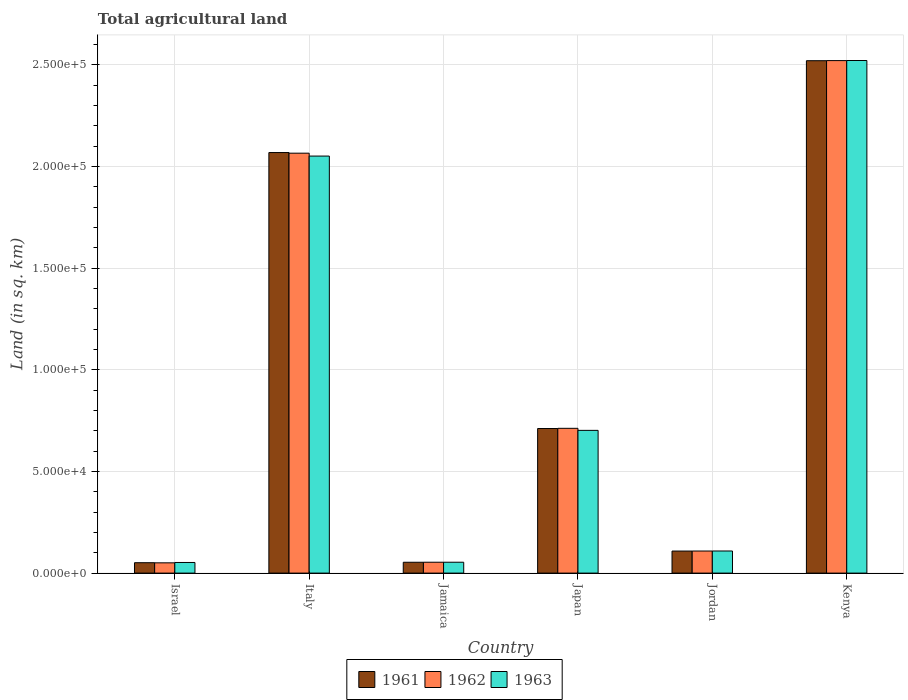Are the number of bars per tick equal to the number of legend labels?
Your answer should be compact. Yes. Are the number of bars on each tick of the X-axis equal?
Keep it short and to the point. Yes. How many bars are there on the 4th tick from the right?
Give a very brief answer. 3. What is the label of the 3rd group of bars from the left?
Make the answer very short. Jamaica. What is the total agricultural land in 1962 in Jamaica?
Provide a short and direct response. 5350. Across all countries, what is the maximum total agricultural land in 1962?
Provide a short and direct response. 2.52e+05. Across all countries, what is the minimum total agricultural land in 1961?
Offer a very short reply. 5110. In which country was the total agricultural land in 1962 maximum?
Your answer should be compact. Kenya. What is the total total agricultural land in 1961 in the graph?
Keep it short and to the point. 5.51e+05. What is the difference between the total agricultural land in 1962 in Jamaica and that in Japan?
Give a very brief answer. -6.58e+04. What is the difference between the total agricultural land in 1962 in Kenya and the total agricultural land in 1963 in Italy?
Give a very brief answer. 4.70e+04. What is the average total agricultural land in 1963 per country?
Offer a terse response. 9.15e+04. What is the ratio of the total agricultural land in 1961 in Italy to that in Jordan?
Ensure brevity in your answer.  19.08. What is the difference between the highest and the second highest total agricultural land in 1961?
Your answer should be very brief. 1.81e+05. What is the difference between the highest and the lowest total agricultural land in 1962?
Offer a very short reply. 2.47e+05. In how many countries, is the total agricultural land in 1963 greater than the average total agricultural land in 1963 taken over all countries?
Your response must be concise. 2. Is the sum of the total agricultural land in 1963 in Israel and Italy greater than the maximum total agricultural land in 1961 across all countries?
Make the answer very short. No. What does the 1st bar from the left in Jamaica represents?
Your response must be concise. 1961. What does the 1st bar from the right in Italy represents?
Give a very brief answer. 1963. Is it the case that in every country, the sum of the total agricultural land in 1962 and total agricultural land in 1963 is greater than the total agricultural land in 1961?
Your answer should be compact. Yes. Are all the bars in the graph horizontal?
Make the answer very short. No. How many countries are there in the graph?
Provide a succinct answer. 6. Are the values on the major ticks of Y-axis written in scientific E-notation?
Ensure brevity in your answer.  Yes. What is the title of the graph?
Offer a terse response. Total agricultural land. Does "1996" appear as one of the legend labels in the graph?
Your answer should be very brief. No. What is the label or title of the Y-axis?
Offer a very short reply. Land (in sq. km). What is the Land (in sq. km) in 1961 in Israel?
Provide a short and direct response. 5110. What is the Land (in sq. km) in 1962 in Israel?
Ensure brevity in your answer.  5050. What is the Land (in sq. km) in 1963 in Israel?
Your answer should be very brief. 5220. What is the Land (in sq. km) in 1961 in Italy?
Offer a terse response. 2.07e+05. What is the Land (in sq. km) in 1962 in Italy?
Keep it short and to the point. 2.07e+05. What is the Land (in sq. km) in 1963 in Italy?
Your response must be concise. 2.05e+05. What is the Land (in sq. km) in 1961 in Jamaica?
Your response must be concise. 5330. What is the Land (in sq. km) of 1962 in Jamaica?
Your response must be concise. 5350. What is the Land (in sq. km) of 1963 in Jamaica?
Give a very brief answer. 5350. What is the Land (in sq. km) in 1961 in Japan?
Make the answer very short. 7.11e+04. What is the Land (in sq. km) in 1962 in Japan?
Offer a terse response. 7.12e+04. What is the Land (in sq. km) of 1963 in Japan?
Keep it short and to the point. 7.02e+04. What is the Land (in sq. km) of 1961 in Jordan?
Your response must be concise. 1.08e+04. What is the Land (in sq. km) of 1962 in Jordan?
Your response must be concise. 1.09e+04. What is the Land (in sq. km) of 1963 in Jordan?
Your answer should be very brief. 1.09e+04. What is the Land (in sq. km) of 1961 in Kenya?
Your answer should be compact. 2.52e+05. What is the Land (in sq. km) in 1962 in Kenya?
Provide a short and direct response. 2.52e+05. What is the Land (in sq. km) in 1963 in Kenya?
Offer a very short reply. 2.52e+05. Across all countries, what is the maximum Land (in sq. km) in 1961?
Keep it short and to the point. 2.52e+05. Across all countries, what is the maximum Land (in sq. km) in 1962?
Offer a very short reply. 2.52e+05. Across all countries, what is the maximum Land (in sq. km) in 1963?
Make the answer very short. 2.52e+05. Across all countries, what is the minimum Land (in sq. km) of 1961?
Your answer should be compact. 5110. Across all countries, what is the minimum Land (in sq. km) of 1962?
Ensure brevity in your answer.  5050. Across all countries, what is the minimum Land (in sq. km) of 1963?
Ensure brevity in your answer.  5220. What is the total Land (in sq. km) of 1961 in the graph?
Keep it short and to the point. 5.51e+05. What is the total Land (in sq. km) of 1962 in the graph?
Ensure brevity in your answer.  5.51e+05. What is the total Land (in sq. km) of 1963 in the graph?
Make the answer very short. 5.49e+05. What is the difference between the Land (in sq. km) of 1961 in Israel and that in Italy?
Ensure brevity in your answer.  -2.02e+05. What is the difference between the Land (in sq. km) in 1962 in Israel and that in Italy?
Make the answer very short. -2.01e+05. What is the difference between the Land (in sq. km) of 1963 in Israel and that in Italy?
Offer a very short reply. -2.00e+05. What is the difference between the Land (in sq. km) in 1961 in Israel and that in Jamaica?
Provide a short and direct response. -220. What is the difference between the Land (in sq. km) in 1962 in Israel and that in Jamaica?
Keep it short and to the point. -300. What is the difference between the Land (in sq. km) of 1963 in Israel and that in Jamaica?
Ensure brevity in your answer.  -130. What is the difference between the Land (in sq. km) of 1961 in Israel and that in Japan?
Your answer should be compact. -6.60e+04. What is the difference between the Land (in sq. km) of 1962 in Israel and that in Japan?
Give a very brief answer. -6.62e+04. What is the difference between the Land (in sq. km) in 1963 in Israel and that in Japan?
Provide a succinct answer. -6.50e+04. What is the difference between the Land (in sq. km) of 1961 in Israel and that in Jordan?
Keep it short and to the point. -5730. What is the difference between the Land (in sq. km) in 1962 in Israel and that in Jordan?
Provide a short and direct response. -5810. What is the difference between the Land (in sq. km) in 1963 in Israel and that in Jordan?
Your response must be concise. -5650. What is the difference between the Land (in sq. km) of 1961 in Israel and that in Kenya?
Ensure brevity in your answer.  -2.47e+05. What is the difference between the Land (in sq. km) in 1962 in Israel and that in Kenya?
Ensure brevity in your answer.  -2.47e+05. What is the difference between the Land (in sq. km) in 1963 in Israel and that in Kenya?
Offer a very short reply. -2.47e+05. What is the difference between the Land (in sq. km) of 1961 in Italy and that in Jamaica?
Your response must be concise. 2.02e+05. What is the difference between the Land (in sq. km) in 1962 in Italy and that in Jamaica?
Your answer should be compact. 2.01e+05. What is the difference between the Land (in sq. km) of 1963 in Italy and that in Jamaica?
Keep it short and to the point. 2.00e+05. What is the difference between the Land (in sq. km) of 1961 in Italy and that in Japan?
Give a very brief answer. 1.36e+05. What is the difference between the Land (in sq. km) of 1962 in Italy and that in Japan?
Provide a short and direct response. 1.35e+05. What is the difference between the Land (in sq. km) in 1963 in Italy and that in Japan?
Ensure brevity in your answer.  1.35e+05. What is the difference between the Land (in sq. km) in 1961 in Italy and that in Jordan?
Your answer should be compact. 1.96e+05. What is the difference between the Land (in sq. km) in 1962 in Italy and that in Jordan?
Provide a short and direct response. 1.96e+05. What is the difference between the Land (in sq. km) of 1963 in Italy and that in Jordan?
Offer a terse response. 1.94e+05. What is the difference between the Land (in sq. km) of 1961 in Italy and that in Kenya?
Your answer should be compact. -4.52e+04. What is the difference between the Land (in sq. km) in 1962 in Italy and that in Kenya?
Your answer should be very brief. -4.55e+04. What is the difference between the Land (in sq. km) of 1963 in Italy and that in Kenya?
Provide a succinct answer. -4.70e+04. What is the difference between the Land (in sq. km) in 1961 in Jamaica and that in Japan?
Give a very brief answer. -6.58e+04. What is the difference between the Land (in sq. km) in 1962 in Jamaica and that in Japan?
Ensure brevity in your answer.  -6.58e+04. What is the difference between the Land (in sq. km) of 1963 in Jamaica and that in Japan?
Offer a very short reply. -6.48e+04. What is the difference between the Land (in sq. km) of 1961 in Jamaica and that in Jordan?
Provide a succinct answer. -5510. What is the difference between the Land (in sq. km) in 1962 in Jamaica and that in Jordan?
Keep it short and to the point. -5510. What is the difference between the Land (in sq. km) of 1963 in Jamaica and that in Jordan?
Ensure brevity in your answer.  -5520. What is the difference between the Land (in sq. km) of 1961 in Jamaica and that in Kenya?
Keep it short and to the point. -2.47e+05. What is the difference between the Land (in sq. km) in 1962 in Jamaica and that in Kenya?
Your answer should be very brief. -2.47e+05. What is the difference between the Land (in sq. km) of 1963 in Jamaica and that in Kenya?
Keep it short and to the point. -2.47e+05. What is the difference between the Land (in sq. km) of 1961 in Japan and that in Jordan?
Provide a succinct answer. 6.03e+04. What is the difference between the Land (in sq. km) in 1962 in Japan and that in Jordan?
Your response must be concise. 6.03e+04. What is the difference between the Land (in sq. km) of 1963 in Japan and that in Jordan?
Your response must be concise. 5.93e+04. What is the difference between the Land (in sq. km) in 1961 in Japan and that in Kenya?
Your response must be concise. -1.81e+05. What is the difference between the Land (in sq. km) of 1962 in Japan and that in Kenya?
Keep it short and to the point. -1.81e+05. What is the difference between the Land (in sq. km) of 1963 in Japan and that in Kenya?
Offer a very short reply. -1.82e+05. What is the difference between the Land (in sq. km) in 1961 in Jordan and that in Kenya?
Provide a succinct answer. -2.41e+05. What is the difference between the Land (in sq. km) of 1962 in Jordan and that in Kenya?
Your answer should be very brief. -2.41e+05. What is the difference between the Land (in sq. km) in 1963 in Jordan and that in Kenya?
Offer a terse response. -2.41e+05. What is the difference between the Land (in sq. km) of 1961 in Israel and the Land (in sq. km) of 1962 in Italy?
Your answer should be compact. -2.01e+05. What is the difference between the Land (in sq. km) in 1961 in Israel and the Land (in sq. km) in 1963 in Italy?
Give a very brief answer. -2.00e+05. What is the difference between the Land (in sq. km) in 1962 in Israel and the Land (in sq. km) in 1963 in Italy?
Give a very brief answer. -2.00e+05. What is the difference between the Land (in sq. km) in 1961 in Israel and the Land (in sq. km) in 1962 in Jamaica?
Your answer should be compact. -240. What is the difference between the Land (in sq. km) in 1961 in Israel and the Land (in sq. km) in 1963 in Jamaica?
Your answer should be compact. -240. What is the difference between the Land (in sq. km) of 1962 in Israel and the Land (in sq. km) of 1963 in Jamaica?
Your response must be concise. -300. What is the difference between the Land (in sq. km) in 1961 in Israel and the Land (in sq. km) in 1962 in Japan?
Make the answer very short. -6.61e+04. What is the difference between the Land (in sq. km) of 1961 in Israel and the Land (in sq. km) of 1963 in Japan?
Your answer should be compact. -6.51e+04. What is the difference between the Land (in sq. km) in 1962 in Israel and the Land (in sq. km) in 1963 in Japan?
Keep it short and to the point. -6.52e+04. What is the difference between the Land (in sq. km) in 1961 in Israel and the Land (in sq. km) in 1962 in Jordan?
Offer a terse response. -5750. What is the difference between the Land (in sq. km) in 1961 in Israel and the Land (in sq. km) in 1963 in Jordan?
Offer a terse response. -5760. What is the difference between the Land (in sq. km) of 1962 in Israel and the Land (in sq. km) of 1963 in Jordan?
Your answer should be compact. -5820. What is the difference between the Land (in sq. km) of 1961 in Israel and the Land (in sq. km) of 1962 in Kenya?
Your answer should be very brief. -2.47e+05. What is the difference between the Land (in sq. km) of 1961 in Israel and the Land (in sq. km) of 1963 in Kenya?
Offer a terse response. -2.47e+05. What is the difference between the Land (in sq. km) in 1962 in Israel and the Land (in sq. km) in 1963 in Kenya?
Make the answer very short. -2.47e+05. What is the difference between the Land (in sq. km) of 1961 in Italy and the Land (in sq. km) of 1962 in Jamaica?
Your answer should be compact. 2.01e+05. What is the difference between the Land (in sq. km) in 1961 in Italy and the Land (in sq. km) in 1963 in Jamaica?
Offer a terse response. 2.01e+05. What is the difference between the Land (in sq. km) of 1962 in Italy and the Land (in sq. km) of 1963 in Jamaica?
Keep it short and to the point. 2.01e+05. What is the difference between the Land (in sq. km) in 1961 in Italy and the Land (in sq. km) in 1962 in Japan?
Make the answer very short. 1.36e+05. What is the difference between the Land (in sq. km) of 1961 in Italy and the Land (in sq. km) of 1963 in Japan?
Give a very brief answer. 1.37e+05. What is the difference between the Land (in sq. km) in 1962 in Italy and the Land (in sq. km) in 1963 in Japan?
Provide a succinct answer. 1.36e+05. What is the difference between the Land (in sq. km) of 1961 in Italy and the Land (in sq. km) of 1962 in Jordan?
Ensure brevity in your answer.  1.96e+05. What is the difference between the Land (in sq. km) of 1961 in Italy and the Land (in sq. km) of 1963 in Jordan?
Give a very brief answer. 1.96e+05. What is the difference between the Land (in sq. km) in 1962 in Italy and the Land (in sq. km) in 1963 in Jordan?
Offer a very short reply. 1.96e+05. What is the difference between the Land (in sq. km) in 1961 in Italy and the Land (in sq. km) in 1962 in Kenya?
Offer a very short reply. -4.52e+04. What is the difference between the Land (in sq. km) of 1961 in Italy and the Land (in sq. km) of 1963 in Kenya?
Your answer should be very brief. -4.53e+04. What is the difference between the Land (in sq. km) of 1962 in Italy and the Land (in sq. km) of 1963 in Kenya?
Provide a short and direct response. -4.56e+04. What is the difference between the Land (in sq. km) in 1961 in Jamaica and the Land (in sq. km) in 1962 in Japan?
Your answer should be very brief. -6.59e+04. What is the difference between the Land (in sq. km) of 1961 in Jamaica and the Land (in sq. km) of 1963 in Japan?
Make the answer very short. -6.49e+04. What is the difference between the Land (in sq. km) of 1962 in Jamaica and the Land (in sq. km) of 1963 in Japan?
Your response must be concise. -6.48e+04. What is the difference between the Land (in sq. km) in 1961 in Jamaica and the Land (in sq. km) in 1962 in Jordan?
Your answer should be very brief. -5530. What is the difference between the Land (in sq. km) in 1961 in Jamaica and the Land (in sq. km) in 1963 in Jordan?
Offer a terse response. -5540. What is the difference between the Land (in sq. km) in 1962 in Jamaica and the Land (in sq. km) in 1963 in Jordan?
Your answer should be very brief. -5520. What is the difference between the Land (in sq. km) of 1961 in Jamaica and the Land (in sq. km) of 1962 in Kenya?
Offer a terse response. -2.47e+05. What is the difference between the Land (in sq. km) of 1961 in Jamaica and the Land (in sq. km) of 1963 in Kenya?
Offer a very short reply. -2.47e+05. What is the difference between the Land (in sq. km) of 1962 in Jamaica and the Land (in sq. km) of 1963 in Kenya?
Ensure brevity in your answer.  -2.47e+05. What is the difference between the Land (in sq. km) in 1961 in Japan and the Land (in sq. km) in 1962 in Jordan?
Give a very brief answer. 6.02e+04. What is the difference between the Land (in sq. km) in 1961 in Japan and the Land (in sq. km) in 1963 in Jordan?
Make the answer very short. 6.02e+04. What is the difference between the Land (in sq. km) in 1962 in Japan and the Land (in sq. km) in 1963 in Jordan?
Make the answer very short. 6.03e+04. What is the difference between the Land (in sq. km) in 1961 in Japan and the Land (in sq. km) in 1962 in Kenya?
Your answer should be very brief. -1.81e+05. What is the difference between the Land (in sq. km) of 1961 in Japan and the Land (in sq. km) of 1963 in Kenya?
Offer a very short reply. -1.81e+05. What is the difference between the Land (in sq. km) in 1962 in Japan and the Land (in sq. km) in 1963 in Kenya?
Your answer should be very brief. -1.81e+05. What is the difference between the Land (in sq. km) of 1961 in Jordan and the Land (in sq. km) of 1962 in Kenya?
Offer a terse response. -2.41e+05. What is the difference between the Land (in sq. km) of 1961 in Jordan and the Land (in sq. km) of 1963 in Kenya?
Your answer should be very brief. -2.41e+05. What is the difference between the Land (in sq. km) in 1962 in Jordan and the Land (in sq. km) in 1963 in Kenya?
Your answer should be very brief. -2.41e+05. What is the average Land (in sq. km) in 1961 per country?
Provide a succinct answer. 9.19e+04. What is the average Land (in sq. km) of 1962 per country?
Provide a short and direct response. 9.18e+04. What is the average Land (in sq. km) in 1963 per country?
Make the answer very short. 9.15e+04. What is the difference between the Land (in sq. km) in 1961 and Land (in sq. km) in 1963 in Israel?
Give a very brief answer. -110. What is the difference between the Land (in sq. km) of 1962 and Land (in sq. km) of 1963 in Israel?
Make the answer very short. -170. What is the difference between the Land (in sq. km) in 1961 and Land (in sq. km) in 1962 in Italy?
Offer a very short reply. 310. What is the difference between the Land (in sq. km) in 1961 and Land (in sq. km) in 1963 in Italy?
Make the answer very short. 1730. What is the difference between the Land (in sq. km) in 1962 and Land (in sq. km) in 1963 in Italy?
Give a very brief answer. 1420. What is the difference between the Land (in sq. km) in 1962 and Land (in sq. km) in 1963 in Jamaica?
Make the answer very short. 0. What is the difference between the Land (in sq. km) in 1961 and Land (in sq. km) in 1962 in Japan?
Ensure brevity in your answer.  -100. What is the difference between the Land (in sq. km) of 1961 and Land (in sq. km) of 1963 in Japan?
Your answer should be compact. 900. What is the difference between the Land (in sq. km) of 1962 and Land (in sq. km) of 1963 in Japan?
Keep it short and to the point. 1000. What is the difference between the Land (in sq. km) in 1961 and Land (in sq. km) in 1962 in Jordan?
Your response must be concise. -20. What is the difference between the Land (in sq. km) in 1962 and Land (in sq. km) in 1963 in Jordan?
Provide a succinct answer. -10. What is the difference between the Land (in sq. km) in 1961 and Land (in sq. km) in 1963 in Kenya?
Provide a succinct answer. -100. What is the ratio of the Land (in sq. km) in 1961 in Israel to that in Italy?
Keep it short and to the point. 0.02. What is the ratio of the Land (in sq. km) of 1962 in Israel to that in Italy?
Offer a terse response. 0.02. What is the ratio of the Land (in sq. km) in 1963 in Israel to that in Italy?
Your answer should be compact. 0.03. What is the ratio of the Land (in sq. km) of 1961 in Israel to that in Jamaica?
Offer a terse response. 0.96. What is the ratio of the Land (in sq. km) in 1962 in Israel to that in Jamaica?
Your response must be concise. 0.94. What is the ratio of the Land (in sq. km) of 1963 in Israel to that in Jamaica?
Your answer should be compact. 0.98. What is the ratio of the Land (in sq. km) in 1961 in Israel to that in Japan?
Your answer should be very brief. 0.07. What is the ratio of the Land (in sq. km) of 1962 in Israel to that in Japan?
Your answer should be very brief. 0.07. What is the ratio of the Land (in sq. km) of 1963 in Israel to that in Japan?
Ensure brevity in your answer.  0.07. What is the ratio of the Land (in sq. km) of 1961 in Israel to that in Jordan?
Provide a short and direct response. 0.47. What is the ratio of the Land (in sq. km) of 1962 in Israel to that in Jordan?
Make the answer very short. 0.47. What is the ratio of the Land (in sq. km) of 1963 in Israel to that in Jordan?
Offer a terse response. 0.48. What is the ratio of the Land (in sq. km) of 1961 in Israel to that in Kenya?
Provide a succinct answer. 0.02. What is the ratio of the Land (in sq. km) of 1963 in Israel to that in Kenya?
Your response must be concise. 0.02. What is the ratio of the Land (in sq. km) of 1961 in Italy to that in Jamaica?
Your answer should be compact. 38.8. What is the ratio of the Land (in sq. km) in 1962 in Italy to that in Jamaica?
Keep it short and to the point. 38.6. What is the ratio of the Land (in sq. km) in 1963 in Italy to that in Jamaica?
Ensure brevity in your answer.  38.34. What is the ratio of the Land (in sq. km) in 1961 in Italy to that in Japan?
Your response must be concise. 2.91. What is the ratio of the Land (in sq. km) of 1962 in Italy to that in Japan?
Keep it short and to the point. 2.9. What is the ratio of the Land (in sq. km) of 1963 in Italy to that in Japan?
Your answer should be very brief. 2.92. What is the ratio of the Land (in sq. km) in 1961 in Italy to that in Jordan?
Make the answer very short. 19.08. What is the ratio of the Land (in sq. km) of 1962 in Italy to that in Jordan?
Give a very brief answer. 19.02. What is the ratio of the Land (in sq. km) of 1963 in Italy to that in Jordan?
Offer a terse response. 18.87. What is the ratio of the Land (in sq. km) of 1961 in Italy to that in Kenya?
Make the answer very short. 0.82. What is the ratio of the Land (in sq. km) in 1962 in Italy to that in Kenya?
Keep it short and to the point. 0.82. What is the ratio of the Land (in sq. km) in 1963 in Italy to that in Kenya?
Your response must be concise. 0.81. What is the ratio of the Land (in sq. km) in 1961 in Jamaica to that in Japan?
Offer a very short reply. 0.07. What is the ratio of the Land (in sq. km) in 1962 in Jamaica to that in Japan?
Make the answer very short. 0.08. What is the ratio of the Land (in sq. km) of 1963 in Jamaica to that in Japan?
Ensure brevity in your answer.  0.08. What is the ratio of the Land (in sq. km) in 1961 in Jamaica to that in Jordan?
Your answer should be very brief. 0.49. What is the ratio of the Land (in sq. km) in 1962 in Jamaica to that in Jordan?
Your answer should be very brief. 0.49. What is the ratio of the Land (in sq. km) in 1963 in Jamaica to that in Jordan?
Your answer should be compact. 0.49. What is the ratio of the Land (in sq. km) in 1961 in Jamaica to that in Kenya?
Make the answer very short. 0.02. What is the ratio of the Land (in sq. km) of 1962 in Jamaica to that in Kenya?
Give a very brief answer. 0.02. What is the ratio of the Land (in sq. km) in 1963 in Jamaica to that in Kenya?
Your answer should be very brief. 0.02. What is the ratio of the Land (in sq. km) of 1961 in Japan to that in Jordan?
Offer a very short reply. 6.56. What is the ratio of the Land (in sq. km) of 1962 in Japan to that in Jordan?
Ensure brevity in your answer.  6.56. What is the ratio of the Land (in sq. km) of 1963 in Japan to that in Jordan?
Keep it short and to the point. 6.46. What is the ratio of the Land (in sq. km) of 1961 in Japan to that in Kenya?
Provide a succinct answer. 0.28. What is the ratio of the Land (in sq. km) of 1962 in Japan to that in Kenya?
Your answer should be very brief. 0.28. What is the ratio of the Land (in sq. km) of 1963 in Japan to that in Kenya?
Offer a very short reply. 0.28. What is the ratio of the Land (in sq. km) of 1961 in Jordan to that in Kenya?
Your response must be concise. 0.04. What is the ratio of the Land (in sq. km) in 1962 in Jordan to that in Kenya?
Your answer should be very brief. 0.04. What is the ratio of the Land (in sq. km) in 1963 in Jordan to that in Kenya?
Provide a succinct answer. 0.04. What is the difference between the highest and the second highest Land (in sq. km) of 1961?
Provide a short and direct response. 4.52e+04. What is the difference between the highest and the second highest Land (in sq. km) of 1962?
Offer a terse response. 4.55e+04. What is the difference between the highest and the second highest Land (in sq. km) in 1963?
Your answer should be compact. 4.70e+04. What is the difference between the highest and the lowest Land (in sq. km) of 1961?
Provide a short and direct response. 2.47e+05. What is the difference between the highest and the lowest Land (in sq. km) of 1962?
Give a very brief answer. 2.47e+05. What is the difference between the highest and the lowest Land (in sq. km) in 1963?
Ensure brevity in your answer.  2.47e+05. 